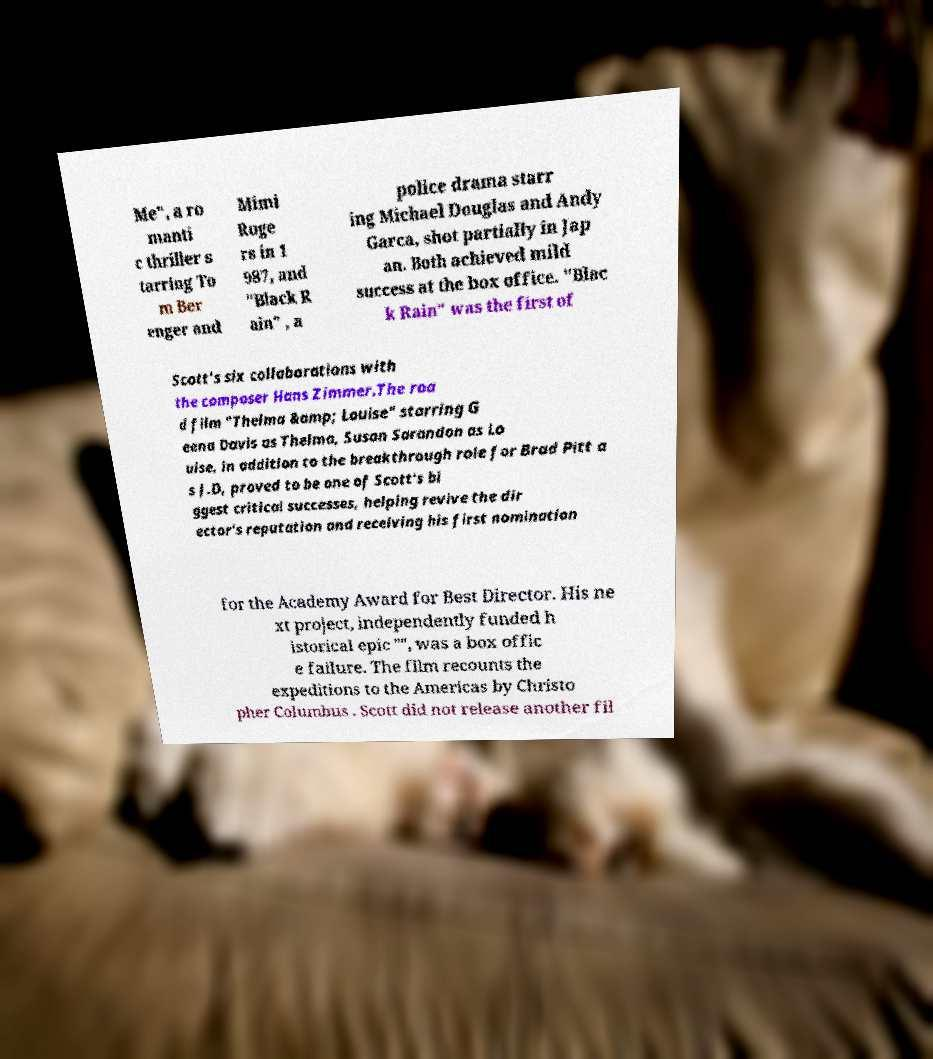Please read and relay the text visible in this image. What does it say? Me", a ro manti c thriller s tarring To m Ber enger and Mimi Roge rs in 1 987, and "Black R ain" , a police drama starr ing Michael Douglas and Andy Garca, shot partially in Jap an. Both achieved mild success at the box office. "Blac k Rain" was the first of Scott's six collaborations with the composer Hans Zimmer.The roa d film "Thelma &amp; Louise" starring G eena Davis as Thelma, Susan Sarandon as Lo uise, in addition to the breakthrough role for Brad Pitt a s J.D, proved to be one of Scott's bi ggest critical successes, helping revive the dir ector's reputation and receiving his first nomination for the Academy Award for Best Director. His ne xt project, independently funded h istorical epic "", was a box offic e failure. The film recounts the expeditions to the Americas by Christo pher Columbus . Scott did not release another fil 